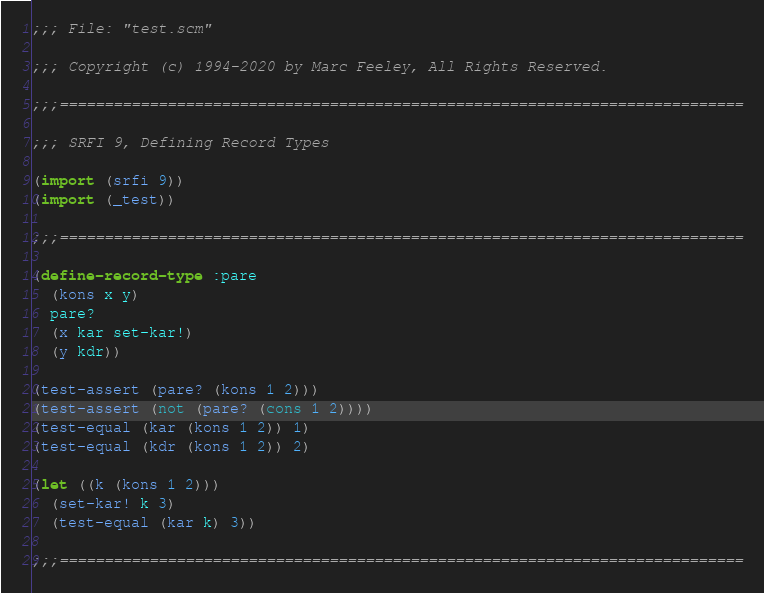Convert code to text. <code><loc_0><loc_0><loc_500><loc_500><_Scheme_>;;; File: "test.scm"

;;; Copyright (c) 1994-2020 by Marc Feeley, All Rights Reserved.

;;;============================================================================

;;; SRFI 9, Defining Record Types

(import (srfi 9))
(import (_test))

;;;============================================================================

(define-record-type :pare
  (kons x y)
  pare?
  (x kar set-kar!)
  (y kdr))

(test-assert (pare? (kons 1 2)))
(test-assert (not (pare? (cons 1 2))))
(test-equal (kar (kons 1 2)) 1)
(test-equal (kdr (kons 1 2)) 2)

(let ((k (kons 1 2)))
  (set-kar! k 3)
  (test-equal (kar k) 3))

;;;============================================================================
</code> 